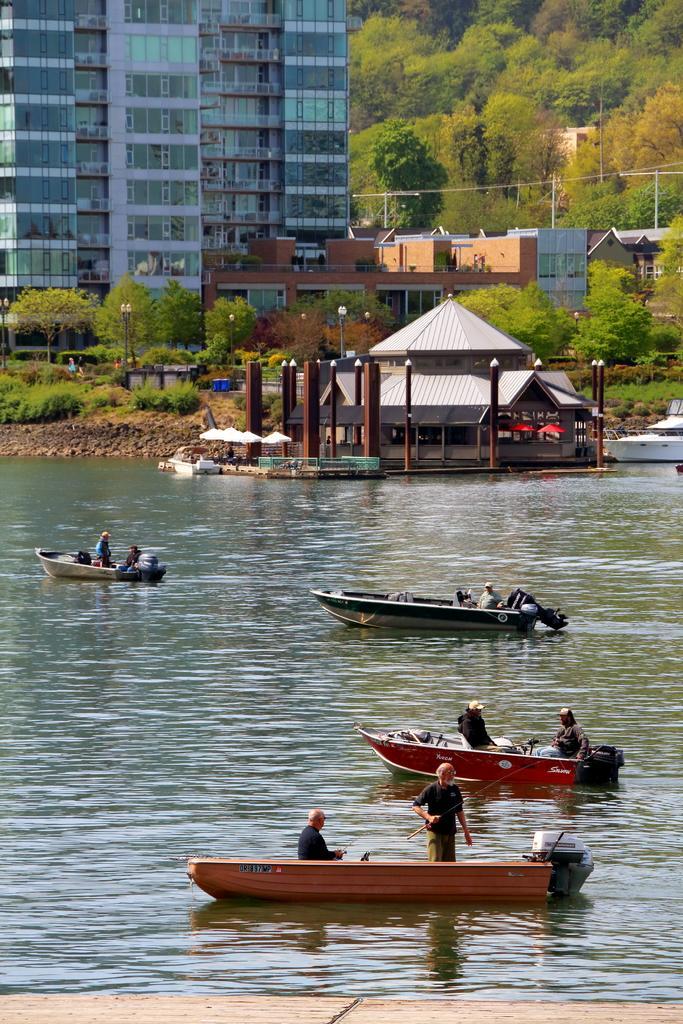In one or two sentences, can you explain what this image depicts? In this image we can see the buildings, trees, light poles and also the house. We can also see the plants, grass and we can see the people in the boats and the boats are present on the surface of the water. 